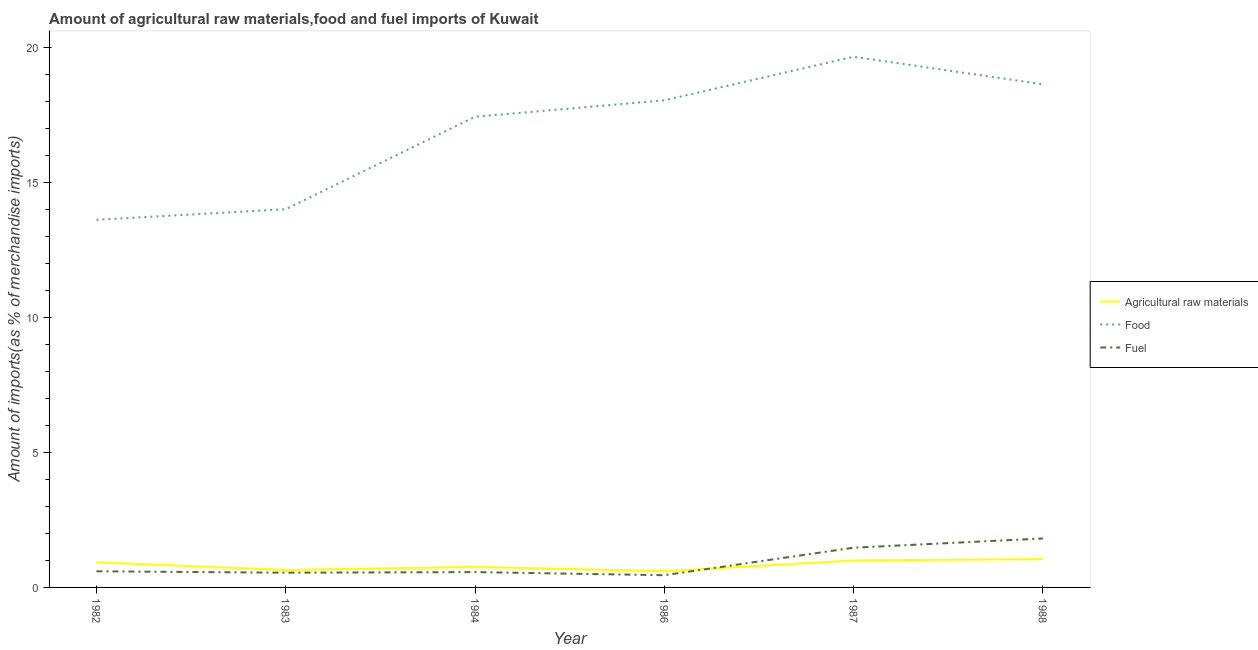What is the percentage of food imports in 1987?
Your response must be concise. 19.64. Across all years, what is the maximum percentage of fuel imports?
Make the answer very short. 1.81. Across all years, what is the minimum percentage of fuel imports?
Ensure brevity in your answer.  0.45. What is the total percentage of fuel imports in the graph?
Your answer should be compact. 5.44. What is the difference between the percentage of raw materials imports in 1982 and that in 1984?
Keep it short and to the point. 0.17. What is the difference between the percentage of fuel imports in 1983 and the percentage of raw materials imports in 1988?
Your answer should be very brief. -0.51. What is the average percentage of fuel imports per year?
Provide a short and direct response. 0.91. In the year 1986, what is the difference between the percentage of fuel imports and percentage of food imports?
Offer a very short reply. -17.57. What is the ratio of the percentage of food imports in 1984 to that in 1988?
Provide a short and direct response. 0.94. Is the percentage of raw materials imports in 1982 less than that in 1983?
Provide a short and direct response. No. What is the difference between the highest and the second highest percentage of fuel imports?
Offer a terse response. 0.34. What is the difference between the highest and the lowest percentage of fuel imports?
Your answer should be compact. 1.36. In how many years, is the percentage of food imports greater than the average percentage of food imports taken over all years?
Make the answer very short. 4. Is it the case that in every year, the sum of the percentage of raw materials imports and percentage of food imports is greater than the percentage of fuel imports?
Provide a short and direct response. Yes. Is the percentage of raw materials imports strictly greater than the percentage of food imports over the years?
Make the answer very short. No. How many lines are there?
Provide a short and direct response. 3. How many years are there in the graph?
Offer a terse response. 6. Does the graph contain grids?
Provide a succinct answer. No. How are the legend labels stacked?
Ensure brevity in your answer.  Vertical. What is the title of the graph?
Ensure brevity in your answer.  Amount of agricultural raw materials,food and fuel imports of Kuwait. What is the label or title of the Y-axis?
Keep it short and to the point. Amount of imports(as % of merchandise imports). What is the Amount of imports(as % of merchandise imports) of Agricultural raw materials in 1982?
Offer a very short reply. 0.93. What is the Amount of imports(as % of merchandise imports) of Food in 1982?
Keep it short and to the point. 13.61. What is the Amount of imports(as % of merchandise imports) in Fuel in 1982?
Make the answer very short. 0.6. What is the Amount of imports(as % of merchandise imports) of Agricultural raw materials in 1983?
Provide a succinct answer. 0.65. What is the Amount of imports(as % of merchandise imports) in Food in 1983?
Ensure brevity in your answer.  14. What is the Amount of imports(as % of merchandise imports) in Fuel in 1983?
Provide a short and direct response. 0.54. What is the Amount of imports(as % of merchandise imports) of Agricultural raw materials in 1984?
Offer a terse response. 0.76. What is the Amount of imports(as % of merchandise imports) in Food in 1984?
Offer a very short reply. 17.42. What is the Amount of imports(as % of merchandise imports) of Fuel in 1984?
Your answer should be compact. 0.57. What is the Amount of imports(as % of merchandise imports) of Agricultural raw materials in 1986?
Your response must be concise. 0.6. What is the Amount of imports(as % of merchandise imports) in Food in 1986?
Your answer should be very brief. 18.03. What is the Amount of imports(as % of merchandise imports) in Fuel in 1986?
Your answer should be compact. 0.45. What is the Amount of imports(as % of merchandise imports) in Agricultural raw materials in 1987?
Your response must be concise. 1. What is the Amount of imports(as % of merchandise imports) of Food in 1987?
Offer a terse response. 19.64. What is the Amount of imports(as % of merchandise imports) in Fuel in 1987?
Keep it short and to the point. 1.47. What is the Amount of imports(as % of merchandise imports) in Agricultural raw materials in 1988?
Your answer should be very brief. 1.05. What is the Amount of imports(as % of merchandise imports) in Food in 1988?
Keep it short and to the point. 18.62. What is the Amount of imports(as % of merchandise imports) in Fuel in 1988?
Your answer should be compact. 1.81. Across all years, what is the maximum Amount of imports(as % of merchandise imports) in Agricultural raw materials?
Your answer should be very brief. 1.05. Across all years, what is the maximum Amount of imports(as % of merchandise imports) of Food?
Keep it short and to the point. 19.64. Across all years, what is the maximum Amount of imports(as % of merchandise imports) of Fuel?
Make the answer very short. 1.81. Across all years, what is the minimum Amount of imports(as % of merchandise imports) of Agricultural raw materials?
Your answer should be compact. 0.6. Across all years, what is the minimum Amount of imports(as % of merchandise imports) of Food?
Provide a succinct answer. 13.61. Across all years, what is the minimum Amount of imports(as % of merchandise imports) in Fuel?
Keep it short and to the point. 0.45. What is the total Amount of imports(as % of merchandise imports) in Agricultural raw materials in the graph?
Make the answer very short. 4.99. What is the total Amount of imports(as % of merchandise imports) of Food in the graph?
Offer a terse response. 101.31. What is the total Amount of imports(as % of merchandise imports) of Fuel in the graph?
Provide a short and direct response. 5.44. What is the difference between the Amount of imports(as % of merchandise imports) of Agricultural raw materials in 1982 and that in 1983?
Provide a short and direct response. 0.28. What is the difference between the Amount of imports(as % of merchandise imports) in Food in 1982 and that in 1983?
Provide a succinct answer. -0.39. What is the difference between the Amount of imports(as % of merchandise imports) of Fuel in 1982 and that in 1983?
Make the answer very short. 0.05. What is the difference between the Amount of imports(as % of merchandise imports) in Agricultural raw materials in 1982 and that in 1984?
Offer a terse response. 0.17. What is the difference between the Amount of imports(as % of merchandise imports) in Food in 1982 and that in 1984?
Give a very brief answer. -3.81. What is the difference between the Amount of imports(as % of merchandise imports) of Fuel in 1982 and that in 1984?
Provide a succinct answer. 0.03. What is the difference between the Amount of imports(as % of merchandise imports) in Agricultural raw materials in 1982 and that in 1986?
Give a very brief answer. 0.33. What is the difference between the Amount of imports(as % of merchandise imports) in Food in 1982 and that in 1986?
Your response must be concise. -4.42. What is the difference between the Amount of imports(as % of merchandise imports) in Fuel in 1982 and that in 1986?
Provide a succinct answer. 0.14. What is the difference between the Amount of imports(as % of merchandise imports) in Agricultural raw materials in 1982 and that in 1987?
Make the answer very short. -0.07. What is the difference between the Amount of imports(as % of merchandise imports) in Food in 1982 and that in 1987?
Provide a succinct answer. -6.04. What is the difference between the Amount of imports(as % of merchandise imports) in Fuel in 1982 and that in 1987?
Ensure brevity in your answer.  -0.87. What is the difference between the Amount of imports(as % of merchandise imports) of Agricultural raw materials in 1982 and that in 1988?
Ensure brevity in your answer.  -0.12. What is the difference between the Amount of imports(as % of merchandise imports) in Food in 1982 and that in 1988?
Your answer should be compact. -5.02. What is the difference between the Amount of imports(as % of merchandise imports) of Fuel in 1982 and that in 1988?
Provide a short and direct response. -1.21. What is the difference between the Amount of imports(as % of merchandise imports) in Agricultural raw materials in 1983 and that in 1984?
Your response must be concise. -0.12. What is the difference between the Amount of imports(as % of merchandise imports) in Food in 1983 and that in 1984?
Make the answer very short. -3.42. What is the difference between the Amount of imports(as % of merchandise imports) in Fuel in 1983 and that in 1984?
Provide a succinct answer. -0.02. What is the difference between the Amount of imports(as % of merchandise imports) of Agricultural raw materials in 1983 and that in 1986?
Offer a very short reply. 0.05. What is the difference between the Amount of imports(as % of merchandise imports) in Food in 1983 and that in 1986?
Provide a short and direct response. -4.03. What is the difference between the Amount of imports(as % of merchandise imports) of Fuel in 1983 and that in 1986?
Provide a short and direct response. 0.09. What is the difference between the Amount of imports(as % of merchandise imports) in Agricultural raw materials in 1983 and that in 1987?
Provide a short and direct response. -0.35. What is the difference between the Amount of imports(as % of merchandise imports) in Food in 1983 and that in 1987?
Ensure brevity in your answer.  -5.64. What is the difference between the Amount of imports(as % of merchandise imports) of Fuel in 1983 and that in 1987?
Give a very brief answer. -0.93. What is the difference between the Amount of imports(as % of merchandise imports) in Agricultural raw materials in 1983 and that in 1988?
Offer a terse response. -0.4. What is the difference between the Amount of imports(as % of merchandise imports) of Food in 1983 and that in 1988?
Offer a very short reply. -4.62. What is the difference between the Amount of imports(as % of merchandise imports) in Fuel in 1983 and that in 1988?
Ensure brevity in your answer.  -1.27. What is the difference between the Amount of imports(as % of merchandise imports) of Agricultural raw materials in 1984 and that in 1986?
Ensure brevity in your answer.  0.16. What is the difference between the Amount of imports(as % of merchandise imports) of Food in 1984 and that in 1986?
Offer a terse response. -0.61. What is the difference between the Amount of imports(as % of merchandise imports) of Fuel in 1984 and that in 1986?
Offer a very short reply. 0.11. What is the difference between the Amount of imports(as % of merchandise imports) in Agricultural raw materials in 1984 and that in 1987?
Provide a succinct answer. -0.24. What is the difference between the Amount of imports(as % of merchandise imports) of Food in 1984 and that in 1987?
Your response must be concise. -2.22. What is the difference between the Amount of imports(as % of merchandise imports) of Fuel in 1984 and that in 1987?
Give a very brief answer. -0.9. What is the difference between the Amount of imports(as % of merchandise imports) of Agricultural raw materials in 1984 and that in 1988?
Provide a short and direct response. -0.29. What is the difference between the Amount of imports(as % of merchandise imports) of Food in 1984 and that in 1988?
Provide a short and direct response. -1.2. What is the difference between the Amount of imports(as % of merchandise imports) in Fuel in 1984 and that in 1988?
Your answer should be compact. -1.25. What is the difference between the Amount of imports(as % of merchandise imports) of Agricultural raw materials in 1986 and that in 1987?
Provide a short and direct response. -0.4. What is the difference between the Amount of imports(as % of merchandise imports) in Food in 1986 and that in 1987?
Ensure brevity in your answer.  -1.61. What is the difference between the Amount of imports(as % of merchandise imports) of Fuel in 1986 and that in 1987?
Ensure brevity in your answer.  -1.02. What is the difference between the Amount of imports(as % of merchandise imports) in Agricultural raw materials in 1986 and that in 1988?
Your answer should be compact. -0.45. What is the difference between the Amount of imports(as % of merchandise imports) of Food in 1986 and that in 1988?
Give a very brief answer. -0.59. What is the difference between the Amount of imports(as % of merchandise imports) in Fuel in 1986 and that in 1988?
Provide a short and direct response. -1.36. What is the difference between the Amount of imports(as % of merchandise imports) in Agricultural raw materials in 1987 and that in 1988?
Offer a terse response. -0.05. What is the difference between the Amount of imports(as % of merchandise imports) in Food in 1987 and that in 1988?
Make the answer very short. 1.02. What is the difference between the Amount of imports(as % of merchandise imports) of Fuel in 1987 and that in 1988?
Offer a terse response. -0.34. What is the difference between the Amount of imports(as % of merchandise imports) in Agricultural raw materials in 1982 and the Amount of imports(as % of merchandise imports) in Food in 1983?
Provide a short and direct response. -13.07. What is the difference between the Amount of imports(as % of merchandise imports) of Agricultural raw materials in 1982 and the Amount of imports(as % of merchandise imports) of Fuel in 1983?
Your response must be concise. 0.39. What is the difference between the Amount of imports(as % of merchandise imports) in Food in 1982 and the Amount of imports(as % of merchandise imports) in Fuel in 1983?
Your answer should be compact. 13.06. What is the difference between the Amount of imports(as % of merchandise imports) of Agricultural raw materials in 1982 and the Amount of imports(as % of merchandise imports) of Food in 1984?
Offer a terse response. -16.49. What is the difference between the Amount of imports(as % of merchandise imports) of Agricultural raw materials in 1982 and the Amount of imports(as % of merchandise imports) of Fuel in 1984?
Provide a succinct answer. 0.36. What is the difference between the Amount of imports(as % of merchandise imports) in Food in 1982 and the Amount of imports(as % of merchandise imports) in Fuel in 1984?
Keep it short and to the point. 13.04. What is the difference between the Amount of imports(as % of merchandise imports) in Agricultural raw materials in 1982 and the Amount of imports(as % of merchandise imports) in Food in 1986?
Give a very brief answer. -17.1. What is the difference between the Amount of imports(as % of merchandise imports) in Agricultural raw materials in 1982 and the Amount of imports(as % of merchandise imports) in Fuel in 1986?
Keep it short and to the point. 0.48. What is the difference between the Amount of imports(as % of merchandise imports) of Food in 1982 and the Amount of imports(as % of merchandise imports) of Fuel in 1986?
Your answer should be compact. 13.15. What is the difference between the Amount of imports(as % of merchandise imports) in Agricultural raw materials in 1982 and the Amount of imports(as % of merchandise imports) in Food in 1987?
Your response must be concise. -18.71. What is the difference between the Amount of imports(as % of merchandise imports) of Agricultural raw materials in 1982 and the Amount of imports(as % of merchandise imports) of Fuel in 1987?
Keep it short and to the point. -0.54. What is the difference between the Amount of imports(as % of merchandise imports) in Food in 1982 and the Amount of imports(as % of merchandise imports) in Fuel in 1987?
Your answer should be very brief. 12.14. What is the difference between the Amount of imports(as % of merchandise imports) in Agricultural raw materials in 1982 and the Amount of imports(as % of merchandise imports) in Food in 1988?
Keep it short and to the point. -17.69. What is the difference between the Amount of imports(as % of merchandise imports) of Agricultural raw materials in 1982 and the Amount of imports(as % of merchandise imports) of Fuel in 1988?
Provide a short and direct response. -0.88. What is the difference between the Amount of imports(as % of merchandise imports) of Food in 1982 and the Amount of imports(as % of merchandise imports) of Fuel in 1988?
Give a very brief answer. 11.79. What is the difference between the Amount of imports(as % of merchandise imports) in Agricultural raw materials in 1983 and the Amount of imports(as % of merchandise imports) in Food in 1984?
Give a very brief answer. -16.77. What is the difference between the Amount of imports(as % of merchandise imports) in Agricultural raw materials in 1983 and the Amount of imports(as % of merchandise imports) in Fuel in 1984?
Make the answer very short. 0.08. What is the difference between the Amount of imports(as % of merchandise imports) in Food in 1983 and the Amount of imports(as % of merchandise imports) in Fuel in 1984?
Your response must be concise. 13.43. What is the difference between the Amount of imports(as % of merchandise imports) of Agricultural raw materials in 1983 and the Amount of imports(as % of merchandise imports) of Food in 1986?
Your response must be concise. -17.38. What is the difference between the Amount of imports(as % of merchandise imports) of Agricultural raw materials in 1983 and the Amount of imports(as % of merchandise imports) of Fuel in 1986?
Provide a succinct answer. 0.19. What is the difference between the Amount of imports(as % of merchandise imports) of Food in 1983 and the Amount of imports(as % of merchandise imports) of Fuel in 1986?
Provide a succinct answer. 13.55. What is the difference between the Amount of imports(as % of merchandise imports) in Agricultural raw materials in 1983 and the Amount of imports(as % of merchandise imports) in Food in 1987?
Offer a very short reply. -18.99. What is the difference between the Amount of imports(as % of merchandise imports) in Agricultural raw materials in 1983 and the Amount of imports(as % of merchandise imports) in Fuel in 1987?
Provide a succinct answer. -0.82. What is the difference between the Amount of imports(as % of merchandise imports) in Food in 1983 and the Amount of imports(as % of merchandise imports) in Fuel in 1987?
Ensure brevity in your answer.  12.53. What is the difference between the Amount of imports(as % of merchandise imports) of Agricultural raw materials in 1983 and the Amount of imports(as % of merchandise imports) of Food in 1988?
Give a very brief answer. -17.98. What is the difference between the Amount of imports(as % of merchandise imports) of Agricultural raw materials in 1983 and the Amount of imports(as % of merchandise imports) of Fuel in 1988?
Ensure brevity in your answer.  -1.17. What is the difference between the Amount of imports(as % of merchandise imports) of Food in 1983 and the Amount of imports(as % of merchandise imports) of Fuel in 1988?
Offer a terse response. 12.19. What is the difference between the Amount of imports(as % of merchandise imports) in Agricultural raw materials in 1984 and the Amount of imports(as % of merchandise imports) in Food in 1986?
Offer a terse response. -17.26. What is the difference between the Amount of imports(as % of merchandise imports) of Agricultural raw materials in 1984 and the Amount of imports(as % of merchandise imports) of Fuel in 1986?
Offer a very short reply. 0.31. What is the difference between the Amount of imports(as % of merchandise imports) in Food in 1984 and the Amount of imports(as % of merchandise imports) in Fuel in 1986?
Provide a short and direct response. 16.97. What is the difference between the Amount of imports(as % of merchandise imports) in Agricultural raw materials in 1984 and the Amount of imports(as % of merchandise imports) in Food in 1987?
Ensure brevity in your answer.  -18.88. What is the difference between the Amount of imports(as % of merchandise imports) of Agricultural raw materials in 1984 and the Amount of imports(as % of merchandise imports) of Fuel in 1987?
Your answer should be very brief. -0.71. What is the difference between the Amount of imports(as % of merchandise imports) of Food in 1984 and the Amount of imports(as % of merchandise imports) of Fuel in 1987?
Make the answer very short. 15.95. What is the difference between the Amount of imports(as % of merchandise imports) of Agricultural raw materials in 1984 and the Amount of imports(as % of merchandise imports) of Food in 1988?
Ensure brevity in your answer.  -17.86. What is the difference between the Amount of imports(as % of merchandise imports) of Agricultural raw materials in 1984 and the Amount of imports(as % of merchandise imports) of Fuel in 1988?
Your answer should be compact. -1.05. What is the difference between the Amount of imports(as % of merchandise imports) in Food in 1984 and the Amount of imports(as % of merchandise imports) in Fuel in 1988?
Your answer should be very brief. 15.61. What is the difference between the Amount of imports(as % of merchandise imports) of Agricultural raw materials in 1986 and the Amount of imports(as % of merchandise imports) of Food in 1987?
Offer a very short reply. -19.04. What is the difference between the Amount of imports(as % of merchandise imports) in Agricultural raw materials in 1986 and the Amount of imports(as % of merchandise imports) in Fuel in 1987?
Offer a very short reply. -0.87. What is the difference between the Amount of imports(as % of merchandise imports) of Food in 1986 and the Amount of imports(as % of merchandise imports) of Fuel in 1987?
Provide a succinct answer. 16.56. What is the difference between the Amount of imports(as % of merchandise imports) of Agricultural raw materials in 1986 and the Amount of imports(as % of merchandise imports) of Food in 1988?
Ensure brevity in your answer.  -18.02. What is the difference between the Amount of imports(as % of merchandise imports) in Agricultural raw materials in 1986 and the Amount of imports(as % of merchandise imports) in Fuel in 1988?
Offer a very short reply. -1.21. What is the difference between the Amount of imports(as % of merchandise imports) in Food in 1986 and the Amount of imports(as % of merchandise imports) in Fuel in 1988?
Ensure brevity in your answer.  16.22. What is the difference between the Amount of imports(as % of merchandise imports) in Agricultural raw materials in 1987 and the Amount of imports(as % of merchandise imports) in Food in 1988?
Ensure brevity in your answer.  -17.62. What is the difference between the Amount of imports(as % of merchandise imports) in Agricultural raw materials in 1987 and the Amount of imports(as % of merchandise imports) in Fuel in 1988?
Offer a very short reply. -0.81. What is the difference between the Amount of imports(as % of merchandise imports) of Food in 1987 and the Amount of imports(as % of merchandise imports) of Fuel in 1988?
Your response must be concise. 17.83. What is the average Amount of imports(as % of merchandise imports) in Agricultural raw materials per year?
Make the answer very short. 0.83. What is the average Amount of imports(as % of merchandise imports) of Food per year?
Ensure brevity in your answer.  16.89. What is the average Amount of imports(as % of merchandise imports) of Fuel per year?
Your answer should be very brief. 0.91. In the year 1982, what is the difference between the Amount of imports(as % of merchandise imports) in Agricultural raw materials and Amount of imports(as % of merchandise imports) in Food?
Give a very brief answer. -12.67. In the year 1982, what is the difference between the Amount of imports(as % of merchandise imports) of Agricultural raw materials and Amount of imports(as % of merchandise imports) of Fuel?
Keep it short and to the point. 0.33. In the year 1982, what is the difference between the Amount of imports(as % of merchandise imports) of Food and Amount of imports(as % of merchandise imports) of Fuel?
Your answer should be compact. 13.01. In the year 1983, what is the difference between the Amount of imports(as % of merchandise imports) of Agricultural raw materials and Amount of imports(as % of merchandise imports) of Food?
Your answer should be compact. -13.35. In the year 1983, what is the difference between the Amount of imports(as % of merchandise imports) of Agricultural raw materials and Amount of imports(as % of merchandise imports) of Fuel?
Offer a terse response. 0.1. In the year 1983, what is the difference between the Amount of imports(as % of merchandise imports) in Food and Amount of imports(as % of merchandise imports) in Fuel?
Keep it short and to the point. 13.45. In the year 1984, what is the difference between the Amount of imports(as % of merchandise imports) of Agricultural raw materials and Amount of imports(as % of merchandise imports) of Food?
Offer a very short reply. -16.66. In the year 1984, what is the difference between the Amount of imports(as % of merchandise imports) of Agricultural raw materials and Amount of imports(as % of merchandise imports) of Fuel?
Your response must be concise. 0.2. In the year 1984, what is the difference between the Amount of imports(as % of merchandise imports) of Food and Amount of imports(as % of merchandise imports) of Fuel?
Give a very brief answer. 16.85. In the year 1986, what is the difference between the Amount of imports(as % of merchandise imports) in Agricultural raw materials and Amount of imports(as % of merchandise imports) in Food?
Give a very brief answer. -17.43. In the year 1986, what is the difference between the Amount of imports(as % of merchandise imports) of Agricultural raw materials and Amount of imports(as % of merchandise imports) of Fuel?
Offer a very short reply. 0.15. In the year 1986, what is the difference between the Amount of imports(as % of merchandise imports) in Food and Amount of imports(as % of merchandise imports) in Fuel?
Keep it short and to the point. 17.57. In the year 1987, what is the difference between the Amount of imports(as % of merchandise imports) of Agricultural raw materials and Amount of imports(as % of merchandise imports) of Food?
Ensure brevity in your answer.  -18.64. In the year 1987, what is the difference between the Amount of imports(as % of merchandise imports) of Agricultural raw materials and Amount of imports(as % of merchandise imports) of Fuel?
Provide a short and direct response. -0.47. In the year 1987, what is the difference between the Amount of imports(as % of merchandise imports) in Food and Amount of imports(as % of merchandise imports) in Fuel?
Make the answer very short. 18.17. In the year 1988, what is the difference between the Amount of imports(as % of merchandise imports) in Agricultural raw materials and Amount of imports(as % of merchandise imports) in Food?
Ensure brevity in your answer.  -17.57. In the year 1988, what is the difference between the Amount of imports(as % of merchandise imports) of Agricultural raw materials and Amount of imports(as % of merchandise imports) of Fuel?
Offer a terse response. -0.76. In the year 1988, what is the difference between the Amount of imports(as % of merchandise imports) of Food and Amount of imports(as % of merchandise imports) of Fuel?
Your response must be concise. 16.81. What is the ratio of the Amount of imports(as % of merchandise imports) of Agricultural raw materials in 1982 to that in 1983?
Keep it short and to the point. 1.44. What is the ratio of the Amount of imports(as % of merchandise imports) in Food in 1982 to that in 1983?
Your response must be concise. 0.97. What is the ratio of the Amount of imports(as % of merchandise imports) in Fuel in 1982 to that in 1983?
Offer a terse response. 1.1. What is the ratio of the Amount of imports(as % of merchandise imports) of Agricultural raw materials in 1982 to that in 1984?
Keep it short and to the point. 1.22. What is the ratio of the Amount of imports(as % of merchandise imports) of Food in 1982 to that in 1984?
Keep it short and to the point. 0.78. What is the ratio of the Amount of imports(as % of merchandise imports) in Fuel in 1982 to that in 1984?
Your response must be concise. 1.05. What is the ratio of the Amount of imports(as % of merchandise imports) of Agricultural raw materials in 1982 to that in 1986?
Your response must be concise. 1.55. What is the ratio of the Amount of imports(as % of merchandise imports) in Food in 1982 to that in 1986?
Your answer should be compact. 0.75. What is the ratio of the Amount of imports(as % of merchandise imports) of Fuel in 1982 to that in 1986?
Your answer should be compact. 1.32. What is the ratio of the Amount of imports(as % of merchandise imports) of Agricultural raw materials in 1982 to that in 1987?
Offer a terse response. 0.93. What is the ratio of the Amount of imports(as % of merchandise imports) of Food in 1982 to that in 1987?
Your response must be concise. 0.69. What is the ratio of the Amount of imports(as % of merchandise imports) in Fuel in 1982 to that in 1987?
Your answer should be very brief. 0.41. What is the ratio of the Amount of imports(as % of merchandise imports) in Agricultural raw materials in 1982 to that in 1988?
Give a very brief answer. 0.89. What is the ratio of the Amount of imports(as % of merchandise imports) in Food in 1982 to that in 1988?
Make the answer very short. 0.73. What is the ratio of the Amount of imports(as % of merchandise imports) in Fuel in 1982 to that in 1988?
Your answer should be very brief. 0.33. What is the ratio of the Amount of imports(as % of merchandise imports) in Agricultural raw materials in 1983 to that in 1984?
Your answer should be very brief. 0.85. What is the ratio of the Amount of imports(as % of merchandise imports) of Food in 1983 to that in 1984?
Provide a short and direct response. 0.8. What is the ratio of the Amount of imports(as % of merchandise imports) of Fuel in 1983 to that in 1984?
Provide a succinct answer. 0.96. What is the ratio of the Amount of imports(as % of merchandise imports) of Agricultural raw materials in 1983 to that in 1986?
Give a very brief answer. 1.08. What is the ratio of the Amount of imports(as % of merchandise imports) in Food in 1983 to that in 1986?
Keep it short and to the point. 0.78. What is the ratio of the Amount of imports(as % of merchandise imports) in Fuel in 1983 to that in 1986?
Offer a very short reply. 1.2. What is the ratio of the Amount of imports(as % of merchandise imports) of Agricultural raw materials in 1983 to that in 1987?
Your answer should be compact. 0.65. What is the ratio of the Amount of imports(as % of merchandise imports) in Food in 1983 to that in 1987?
Your answer should be compact. 0.71. What is the ratio of the Amount of imports(as % of merchandise imports) of Fuel in 1983 to that in 1987?
Give a very brief answer. 0.37. What is the ratio of the Amount of imports(as % of merchandise imports) in Agricultural raw materials in 1983 to that in 1988?
Offer a terse response. 0.62. What is the ratio of the Amount of imports(as % of merchandise imports) of Food in 1983 to that in 1988?
Your response must be concise. 0.75. What is the ratio of the Amount of imports(as % of merchandise imports) of Fuel in 1983 to that in 1988?
Keep it short and to the point. 0.3. What is the ratio of the Amount of imports(as % of merchandise imports) of Agricultural raw materials in 1984 to that in 1986?
Give a very brief answer. 1.27. What is the ratio of the Amount of imports(as % of merchandise imports) in Food in 1984 to that in 1986?
Your answer should be very brief. 0.97. What is the ratio of the Amount of imports(as % of merchandise imports) in Fuel in 1984 to that in 1986?
Give a very brief answer. 1.25. What is the ratio of the Amount of imports(as % of merchandise imports) in Agricultural raw materials in 1984 to that in 1987?
Offer a terse response. 0.76. What is the ratio of the Amount of imports(as % of merchandise imports) of Food in 1984 to that in 1987?
Make the answer very short. 0.89. What is the ratio of the Amount of imports(as % of merchandise imports) of Fuel in 1984 to that in 1987?
Ensure brevity in your answer.  0.39. What is the ratio of the Amount of imports(as % of merchandise imports) of Agricultural raw materials in 1984 to that in 1988?
Give a very brief answer. 0.73. What is the ratio of the Amount of imports(as % of merchandise imports) in Food in 1984 to that in 1988?
Provide a short and direct response. 0.94. What is the ratio of the Amount of imports(as % of merchandise imports) of Fuel in 1984 to that in 1988?
Give a very brief answer. 0.31. What is the ratio of the Amount of imports(as % of merchandise imports) of Agricultural raw materials in 1986 to that in 1987?
Ensure brevity in your answer.  0.6. What is the ratio of the Amount of imports(as % of merchandise imports) in Food in 1986 to that in 1987?
Provide a succinct answer. 0.92. What is the ratio of the Amount of imports(as % of merchandise imports) in Fuel in 1986 to that in 1987?
Provide a short and direct response. 0.31. What is the ratio of the Amount of imports(as % of merchandise imports) of Agricultural raw materials in 1986 to that in 1988?
Your answer should be very brief. 0.57. What is the ratio of the Amount of imports(as % of merchandise imports) of Fuel in 1986 to that in 1988?
Your answer should be compact. 0.25. What is the ratio of the Amount of imports(as % of merchandise imports) in Agricultural raw materials in 1987 to that in 1988?
Keep it short and to the point. 0.95. What is the ratio of the Amount of imports(as % of merchandise imports) in Food in 1987 to that in 1988?
Give a very brief answer. 1.05. What is the ratio of the Amount of imports(as % of merchandise imports) of Fuel in 1987 to that in 1988?
Offer a terse response. 0.81. What is the difference between the highest and the second highest Amount of imports(as % of merchandise imports) of Agricultural raw materials?
Your answer should be compact. 0.05. What is the difference between the highest and the second highest Amount of imports(as % of merchandise imports) of Food?
Offer a very short reply. 1.02. What is the difference between the highest and the second highest Amount of imports(as % of merchandise imports) of Fuel?
Your answer should be compact. 0.34. What is the difference between the highest and the lowest Amount of imports(as % of merchandise imports) in Agricultural raw materials?
Provide a succinct answer. 0.45. What is the difference between the highest and the lowest Amount of imports(as % of merchandise imports) of Food?
Provide a succinct answer. 6.04. What is the difference between the highest and the lowest Amount of imports(as % of merchandise imports) in Fuel?
Keep it short and to the point. 1.36. 